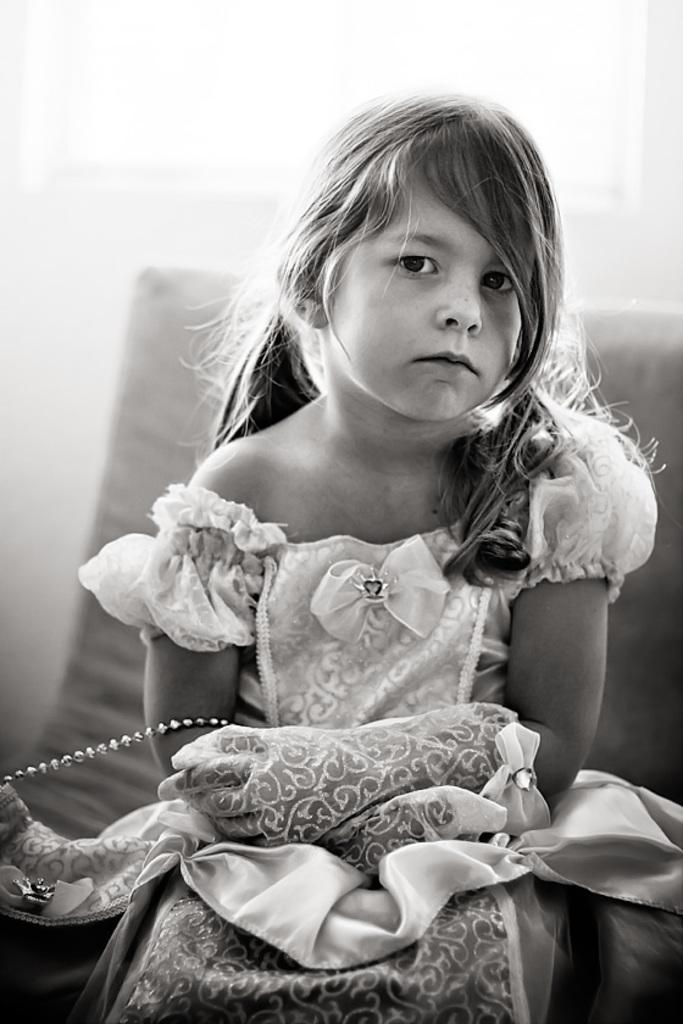What is the color scheme of the image? The image is black and white. Who is present in the image? There is a girl in the image. What is the girl doing in the image? The girl is sitting on a sofa. What type of twig can be seen in the girl's hand in the image? There is no twig present in the girl's hand or in the image. How does the family interact with each other in the image? There is no family present in the image, only a girl sitting on a sofa. 